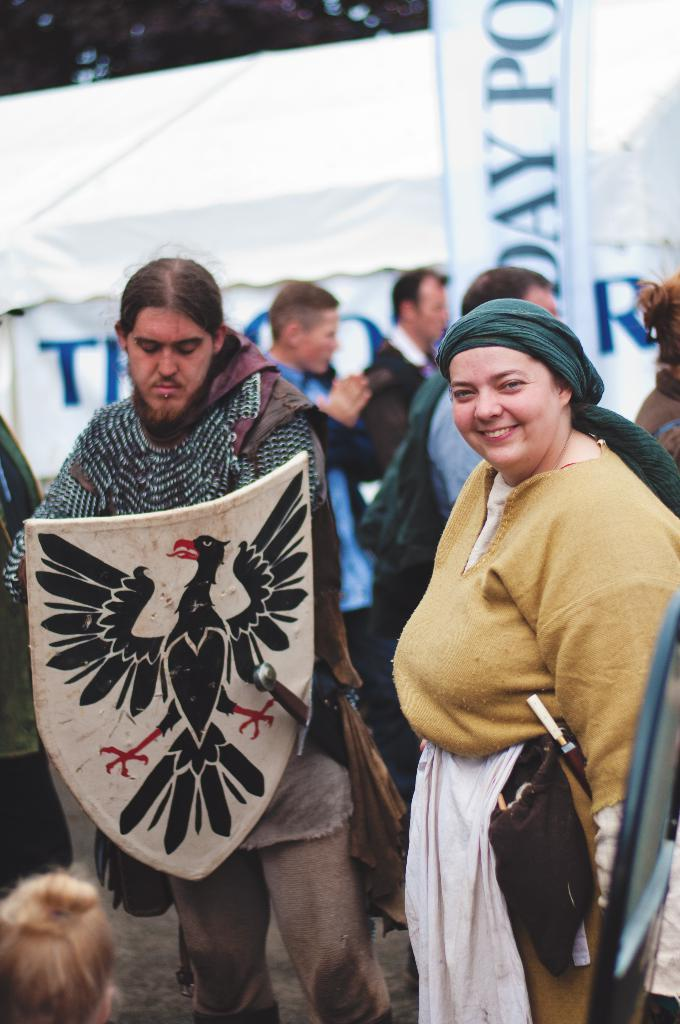How many people are in the image? There is a group of people in the image. What are the people doing in the image? The people are on the ground. What objects can be seen in the image related to protection or combat? There is a shield and swords in the image. What can be seen in the background of the image? There are banners in the background of the image. Can you see a mask on any of the people in the image? There is no mask visible on any of the people in the image. What type of seed is being planted by the people in the image? There is no indication of planting or seeds in the image; the focus is on the group of people, their position, and the presence of a shield and swords. 